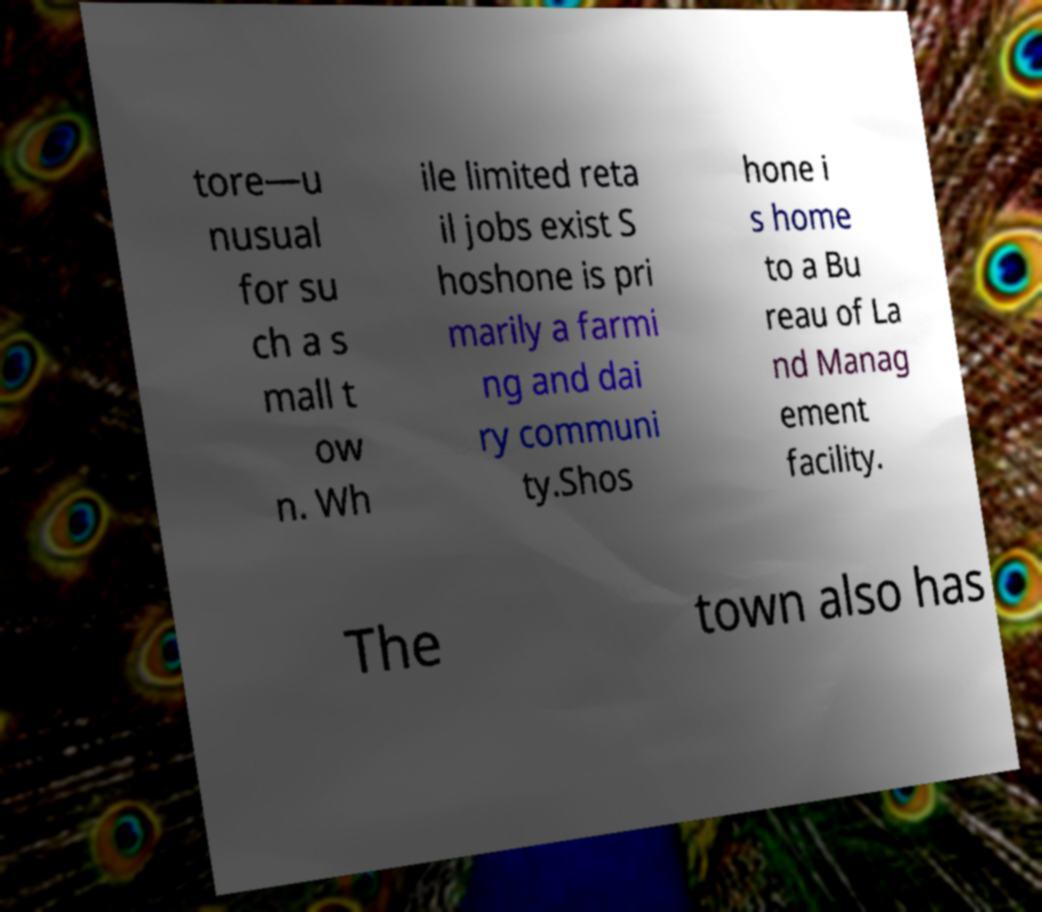Could you extract and type out the text from this image? tore—u nusual for su ch a s mall t ow n. Wh ile limited reta il jobs exist S hoshone is pri marily a farmi ng and dai ry communi ty.Shos hone i s home to a Bu reau of La nd Manag ement facility. The town also has 